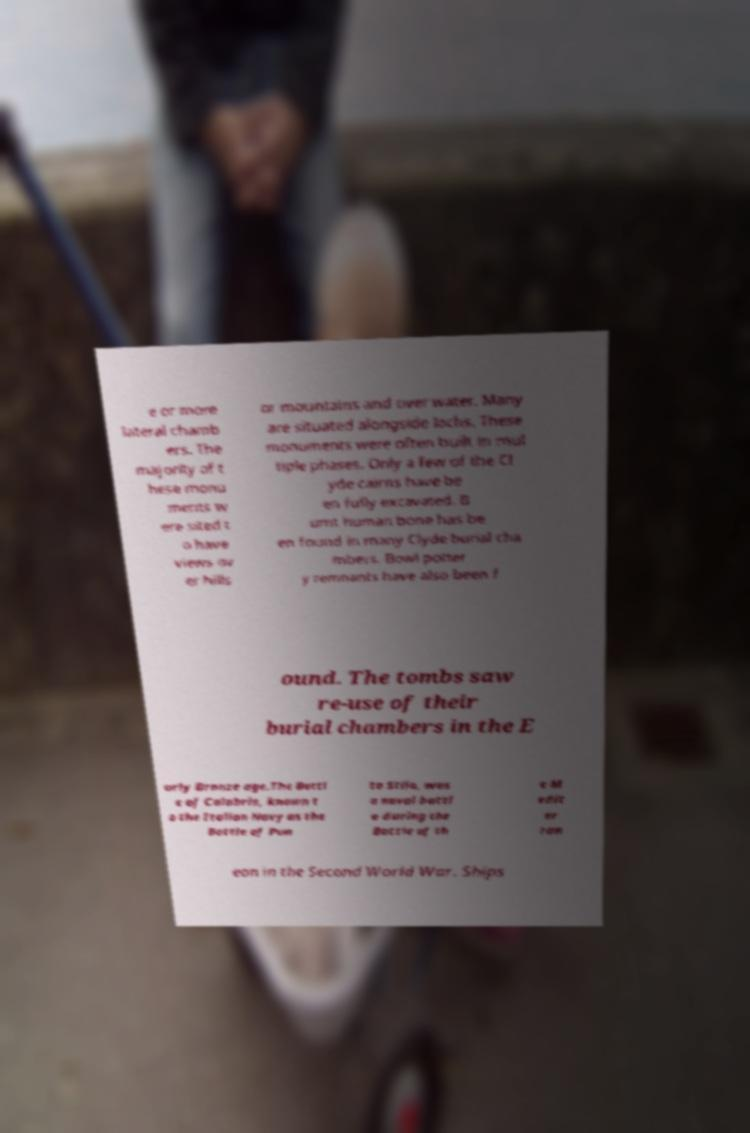What messages or text are displayed in this image? I need them in a readable, typed format. e or more lateral chamb ers. The majority of t hese monu ments w ere sited t o have views ov er hills or mountains and over water. Many are situated alongside lochs. These monuments were often built in mul tiple phases. Only a few of the Cl yde cairns have be en fully excavated. B urnt human bone has be en found in many Clyde burial cha mbers. Bowl potter y remnants have also been f ound. The tombs saw re-use of their burial chambers in the E arly Bronze age.The Battl e of Calabria, known t o the Italian Navy as the Battle of Pun ta Stilo, was a naval battl e during the Battle of th e M edit er ran ean in the Second World War. Ships 